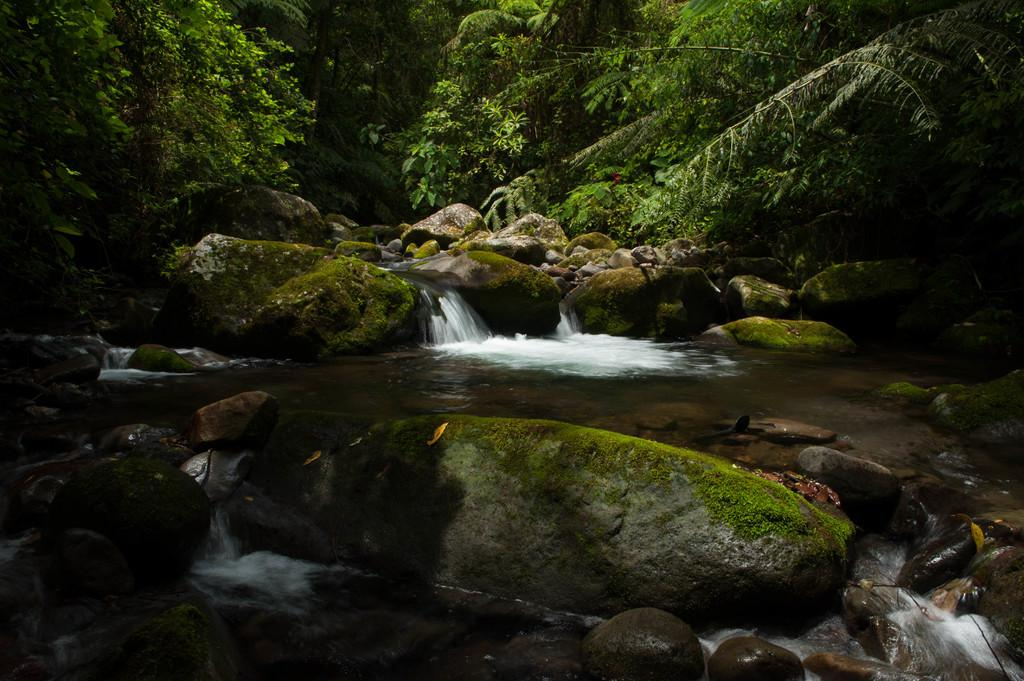What type of natural elements can be seen in the image? There are trees, rocks, and water visible in the image. What additional detail can be observed on the ground? Dried leaves are present in the image. What type of can is depicted in the scene? There is no can present in the image; it features natural elements such as trees, rocks, water, and dried leaves. Are there any berries visible in the image? There are no berries present in the image. 